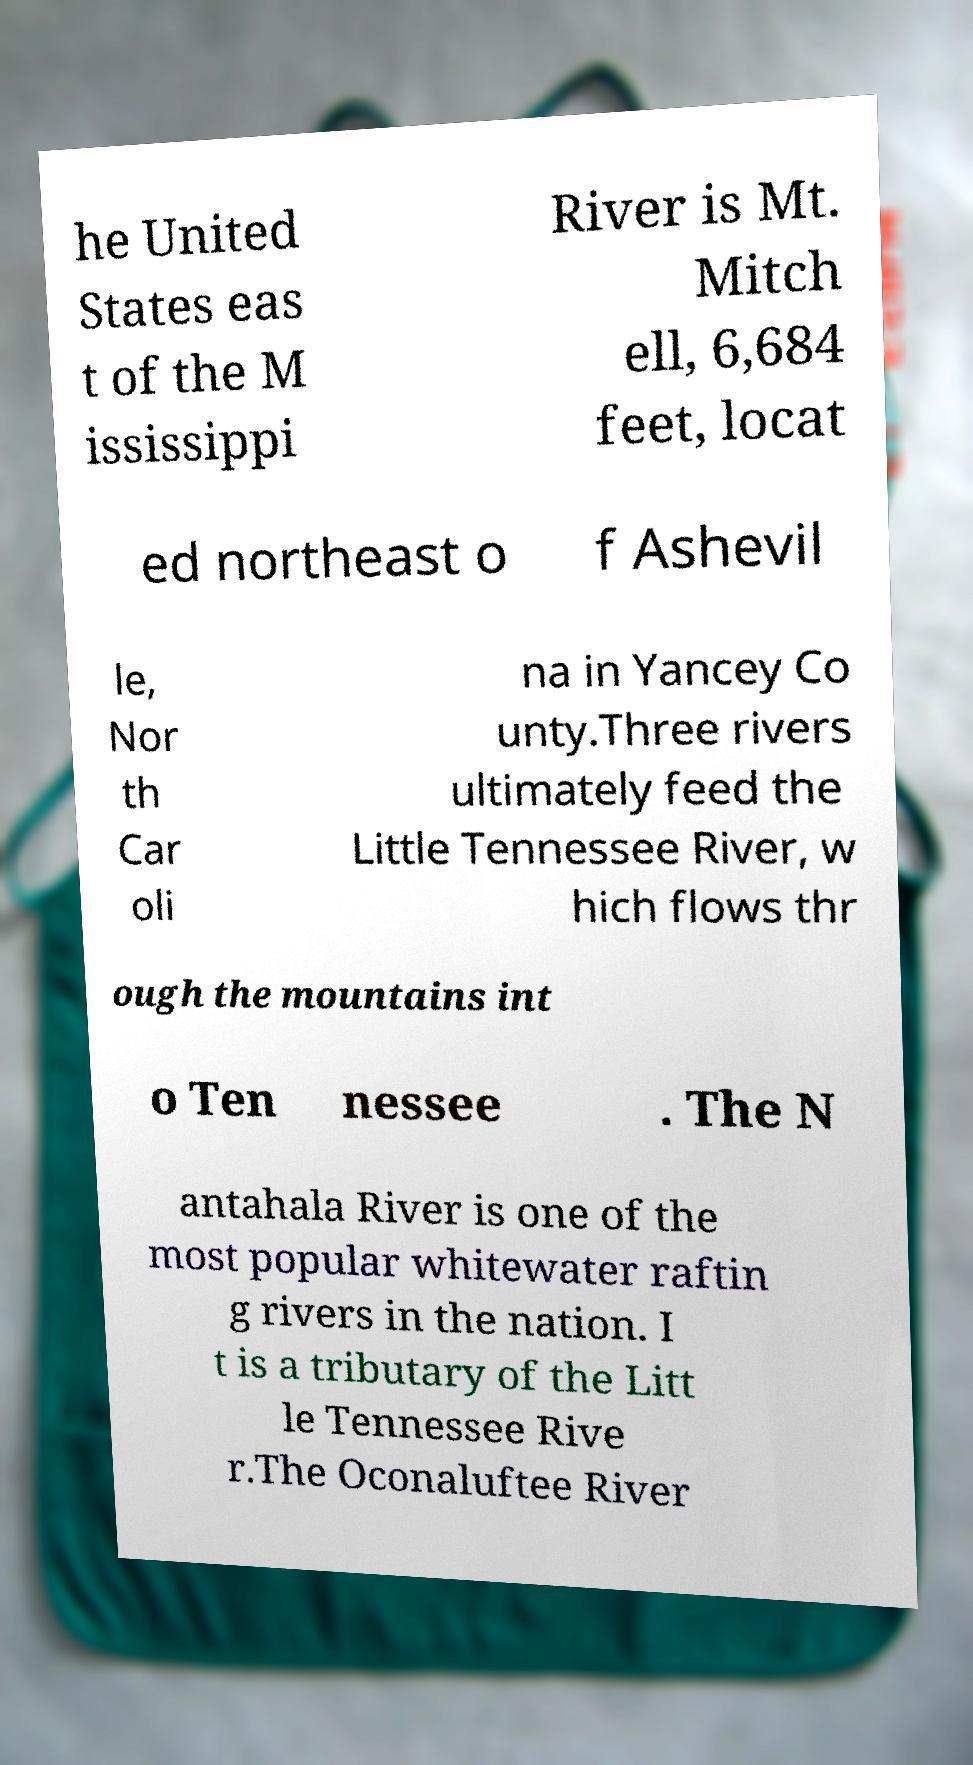Can you read and provide the text displayed in the image?This photo seems to have some interesting text. Can you extract and type it out for me? he United States eas t of the M ississippi River is Mt. Mitch ell, 6,684 feet, locat ed northeast o f Ashevil le, Nor th Car oli na in Yancey Co unty.Three rivers ultimately feed the Little Tennessee River, w hich flows thr ough the mountains int o Ten nessee . The N antahala River is one of the most popular whitewater raftin g rivers in the nation. I t is a tributary of the Litt le Tennessee Rive r.The Oconaluftee River 